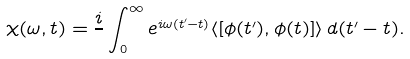Convert formula to latex. <formula><loc_0><loc_0><loc_500><loc_500>\chi ( \omega , t ) = \frac { i } { } \int _ { 0 } ^ { \infty } e ^ { i \omega ( t ^ { \prime } - t ) } \langle \left [ \phi ( t ^ { \prime } ) , \phi ( t ) \right ] \rangle \, d ( t ^ { \prime } - t ) .</formula> 